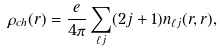<formula> <loc_0><loc_0><loc_500><loc_500>\rho _ { c h } ( r ) = \frac { e } { 4 \pi } \sum _ { \ell j } ( 2 j + 1 ) n _ { \ell j } ( r , r ) ,</formula> 